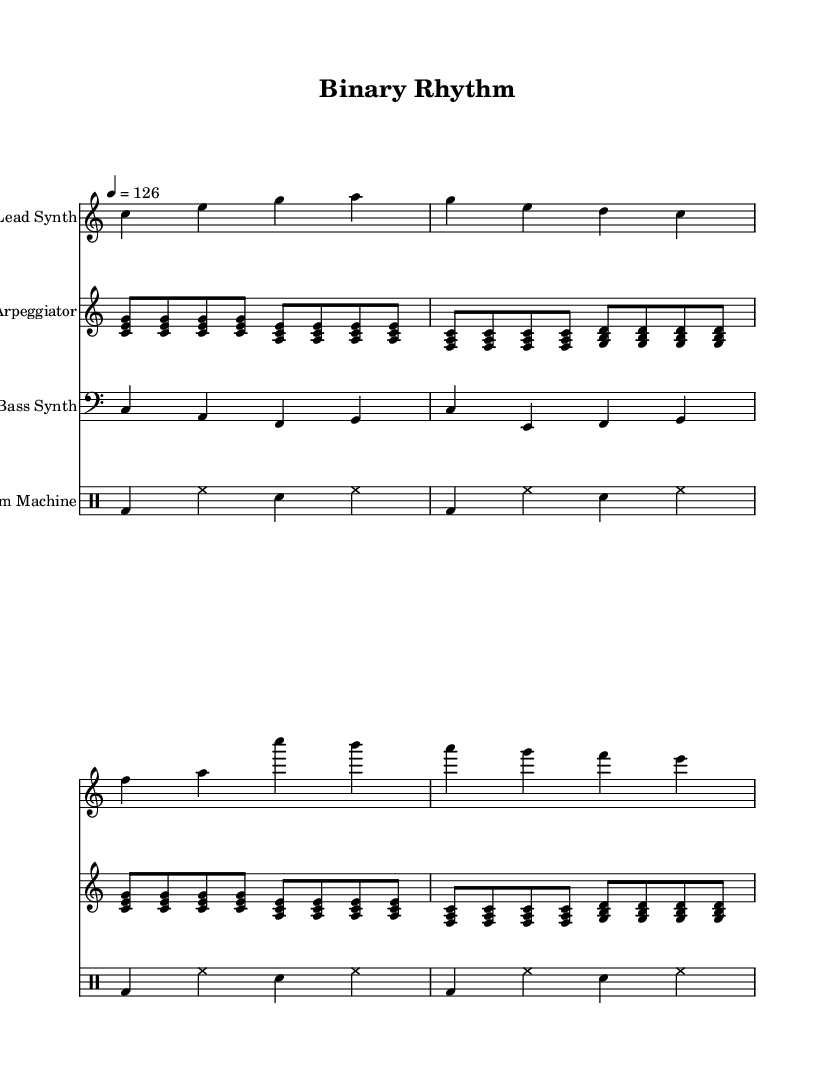What is the key signature of this music? The key signature is C major, which has no sharps or flats.
Answer: C major What is the time signature of this piece? The time signature, indicated at the beginning of the score, is 4/4, meaning there are four beats in each measure.
Answer: 4/4 What is the tempo of this track? The tempo marking shows that the piece is set at a speed of 126 beats per minute.
Answer: 126 How many measures are in the lead synth part? By counting the individual sets of notes in the lead synth, I identified 4 measures based on the bar lines.
Answer: 4 What instruments are featured in this piece? The score identifies four unique instruments: Lead Synth, Arpeggiator, Bass Synth, and Drum Machine. Each is specified at the start of their respective staff.
Answer: Lead Synth, Arpeggiator, Bass Synth, Drum Machine Which rhythmic pattern is used in the drum machine section? The drum machine part repeats a pattern made up of bass drum, hi-hat, and snare drum in a consistent 4/4 rhythm, showing a driving beat typical of electronic music.
Answer: bass, hi-hat, snare What type of electronic music is this track inspired by? The overall style incorporates elements of synthwave, a genre characterized by nostalgic sounds reminiscent of retro computer technology, synths, and upbeat rhythms.
Answer: synthwave 